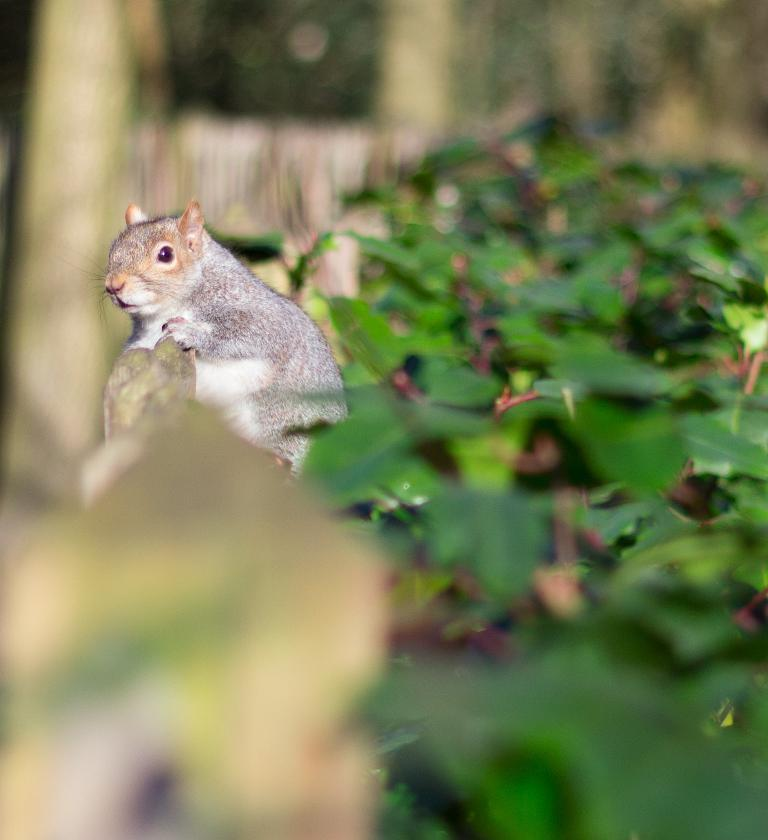What animal can be seen in the image? There is a squirrel in the image. What is the squirrel doing in the image? The squirrel is on an object. What type of vegetation is present on the right side of the image? There are leaves on the right side of the image. How would you describe the background of the image? The background of the image is blurred. What type of behavior is the squirrel exhibiting while driving in the image? There is no indication that the squirrel is driving in the image, and therefore no behavior related to driving can be observed. 